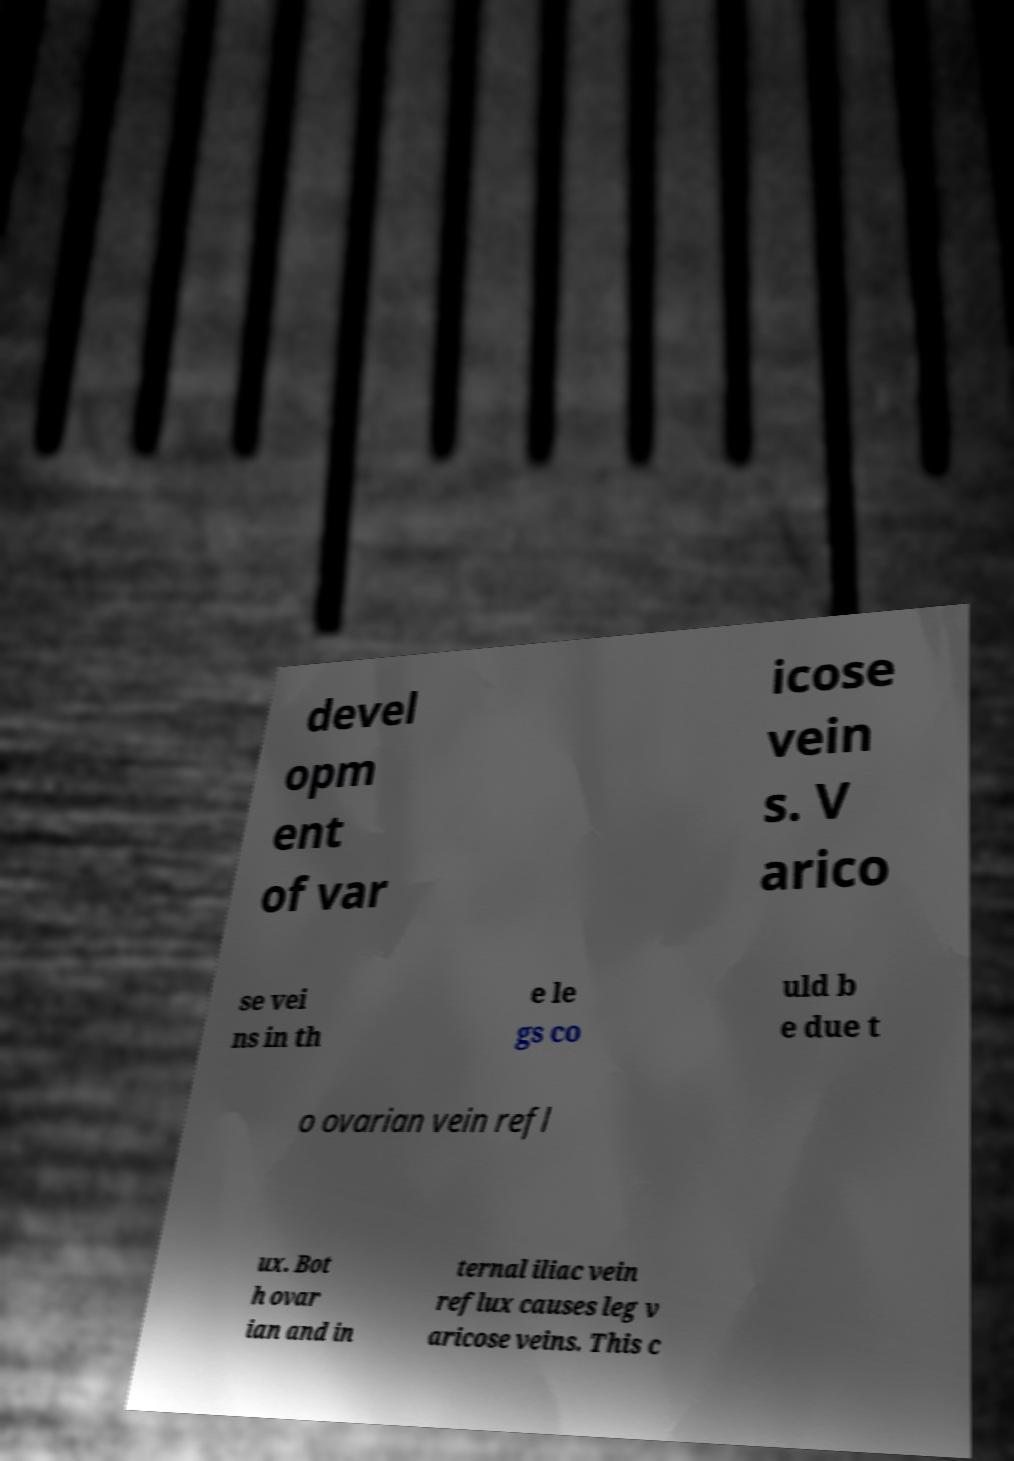Can you accurately transcribe the text from the provided image for me? devel opm ent of var icose vein s. V arico se vei ns in th e le gs co uld b e due t o ovarian vein refl ux. Bot h ovar ian and in ternal iliac vein reflux causes leg v aricose veins. This c 